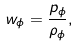Convert formula to latex. <formula><loc_0><loc_0><loc_500><loc_500>w _ { \phi } = \frac { p _ { \phi } } { \rho _ { \phi } } ,</formula> 